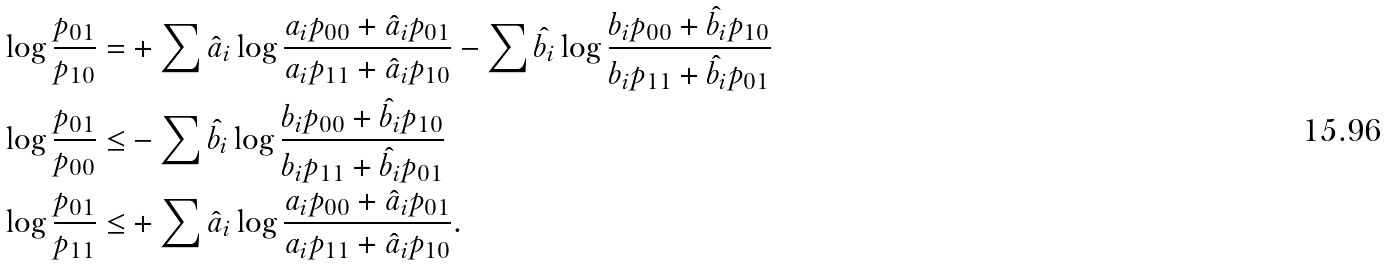Convert formula to latex. <formula><loc_0><loc_0><loc_500><loc_500>\log \frac { p _ { 0 1 } } { p _ { 1 0 } } = & + \sum \hat { a } _ { i } \log \frac { a _ { i } p _ { 0 0 } + \hat { a } _ { i } p _ { 0 1 } } { a _ { i } p _ { 1 1 } + \hat { a } _ { i } p _ { 1 0 } } - \sum \hat { b } _ { i } \log \frac { b _ { i } p _ { 0 0 } + \hat { b } _ { i } p _ { 1 0 } } { b _ { i } p _ { 1 1 } + \hat { b } _ { i } p _ { 0 1 } } \\ \log \frac { p _ { 0 1 } } { p _ { 0 0 } } \leq & - \sum \hat { b } _ { i } \log \frac { b _ { i } p _ { 0 0 } + \hat { b } _ { i } p _ { 1 0 } } { b _ { i } p _ { 1 1 } + \hat { b } _ { i } p _ { 0 1 } } \\ \log \frac { p _ { 0 1 } } { p _ { 1 1 } } \leq & + \sum \hat { a } _ { i } \log \frac { a _ { i } p _ { 0 0 } + \hat { a } _ { i } p _ { 0 1 } } { a _ { i } p _ { 1 1 } + \hat { a } _ { i } p _ { 1 0 } } .</formula> 